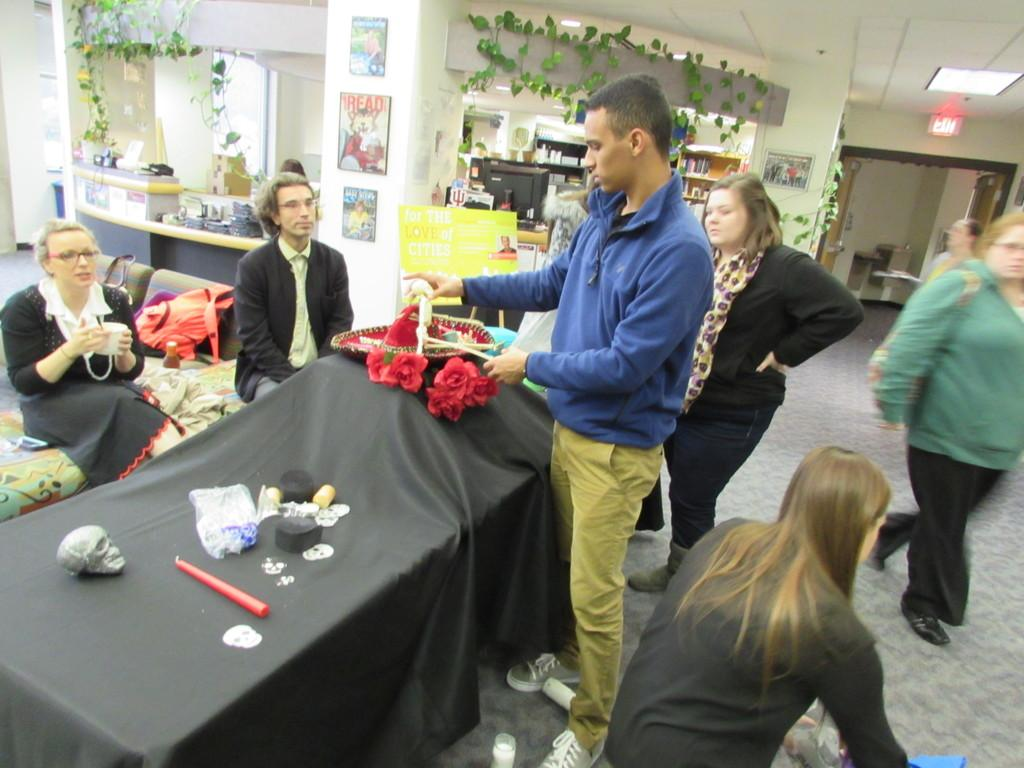How many people are in the image? There is a group of people in the image. What are the people doing in the image? The group of people is around a table. What is the color of the tablecloth? The table has a black cloth. What can be seen on the table? There are objects on the table. What type of protest is happening in the image? There is no protest present in the image. How many houses are visible in the image? There are no houses visible in the image. 